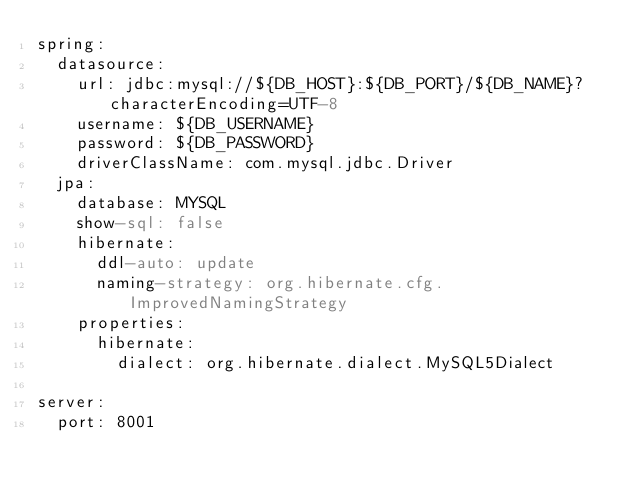Convert code to text. <code><loc_0><loc_0><loc_500><loc_500><_YAML_>spring:
  datasource:
    url: jdbc:mysql://${DB_HOST}:${DB_PORT}/${DB_NAME}?characterEncoding=UTF-8
    username: ${DB_USERNAME}
    password: ${DB_PASSWORD}
    driverClassName: com.mysql.jdbc.Driver
  jpa:
    database: MYSQL
    show-sql: false
    hibernate:
      ddl-auto: update
      naming-strategy: org.hibernate.cfg.ImprovedNamingStrategy
    properties:
      hibernate:
        dialect: org.hibernate.dialect.MySQL5Dialect

server:
  port: 8001</code> 